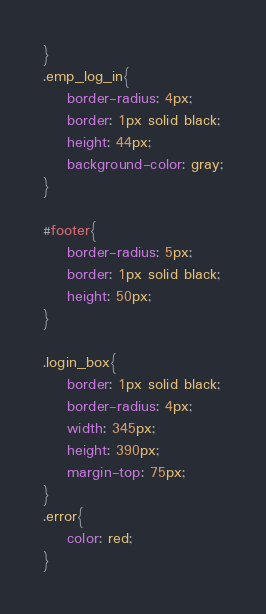Convert code to text. <code><loc_0><loc_0><loc_500><loc_500><_CSS_>}
.emp_log_in{
	border-radius: 4px;
	border: 1px solid black;
	height: 44px;
	background-color: gray;
}

#footer{
    border-radius: 5px;
    border: 1px solid black;
    height: 50px;
}

.login_box{
	border: 1px solid black;
	border-radius: 4px;
	width: 345px;
	height: 390px;
	margin-top: 75px;
}
.error{
	color: red;
}</code> 